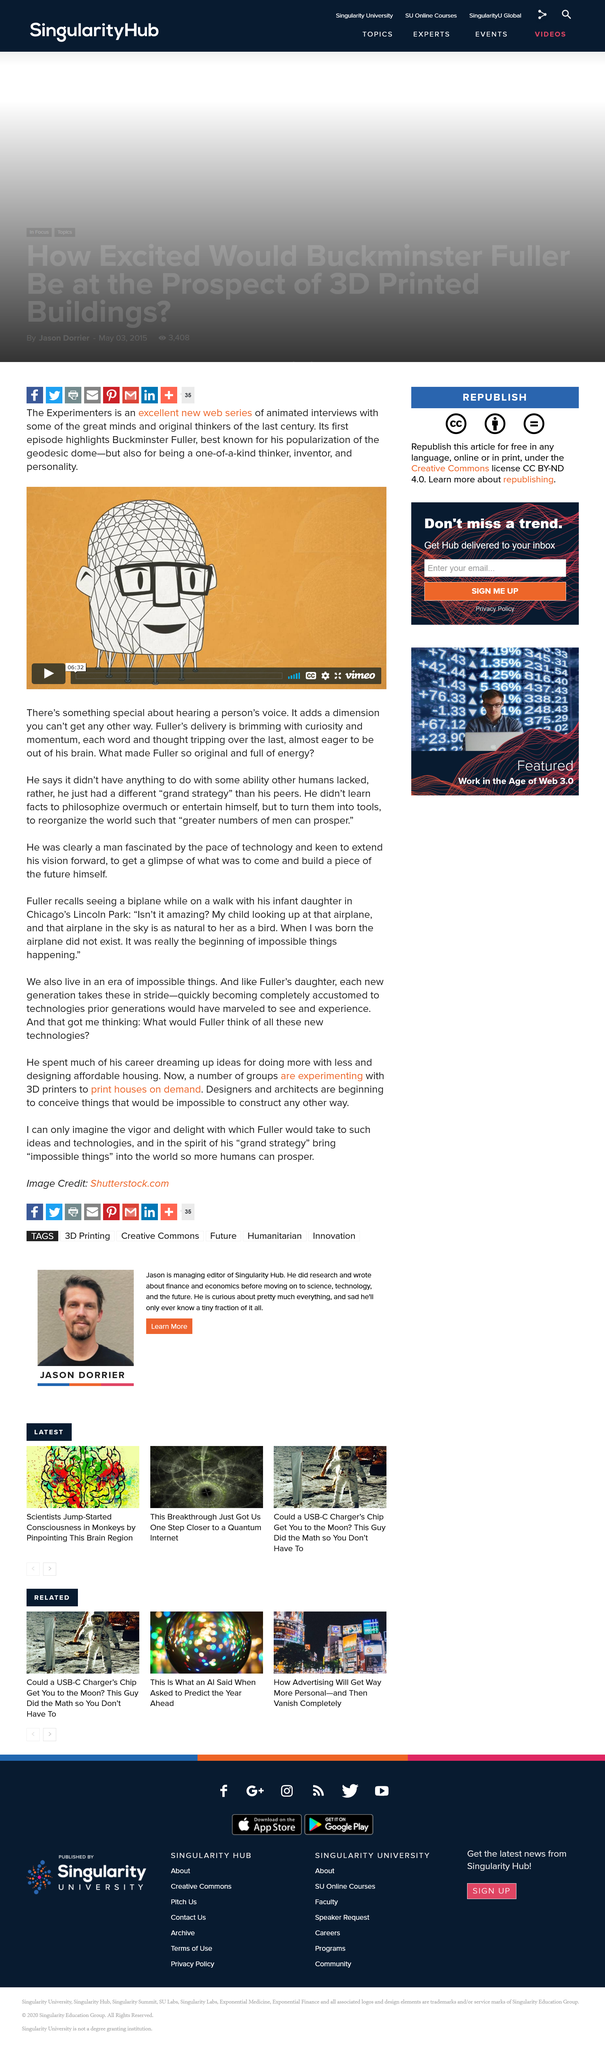Outline some significant characteristics in this image. The speaker is informing the listener that they can listen to an interview with Buckminster Fuller on "The Experimenters," a web series of animated interviews with notable thinkers and original minds from the last century. Buckminster Fuller is credited with popularizing the invention of the geodesic dome. Buckminster Fuller worked in the 20th century. 